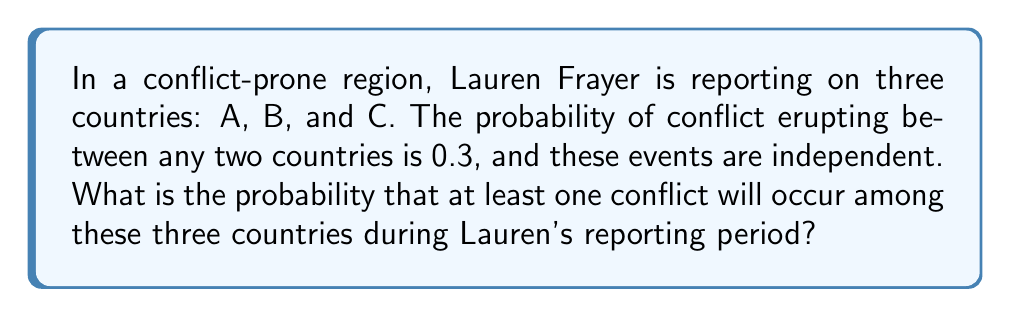Show me your answer to this math problem. Let's approach this step-by-step:

1) First, we need to identify the possible pairs of countries that could engage in conflict:
   - A and B
   - A and C
   - B and C

2) We're told that the probability of conflict between any two countries is 0.3, and these events are independent.

3) It's easier to calculate the probability of at least one conflict occurring by first calculating the probability of no conflicts occurring and then subtracting this from 1.

4) The probability of no conflict between a pair of countries is:
   $1 - 0.3 = 0.7$

5) For no conflicts to occur at all, we need peace between all three pairs. Since the events are independent, we multiply these probabilities:

   $P(\text{no conflicts}) = 0.7 \times 0.7 \times 0.7 = 0.7^3 = 0.343$

6) Therefore, the probability of at least one conflict is:

   $P(\text{at least one conflict}) = 1 - P(\text{no conflicts})$
   $= 1 - 0.343 = 0.657$

7) We can express this as a percentage:
   $0.657 \times 100\% = 65.7\%$
Answer: 65.7% 